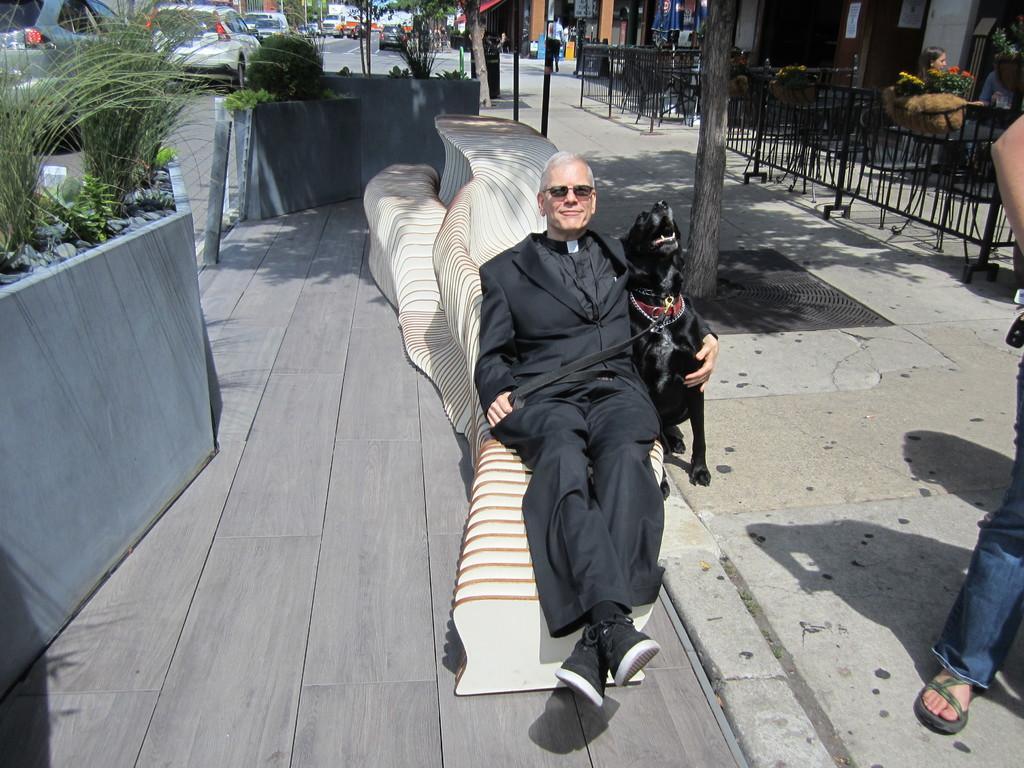How would you summarize this image in a sentence or two? This is the e picture of a man in black suit and holding a dog and lying on the thing in the street and beside him there is a plant, cars and some shops around him. 